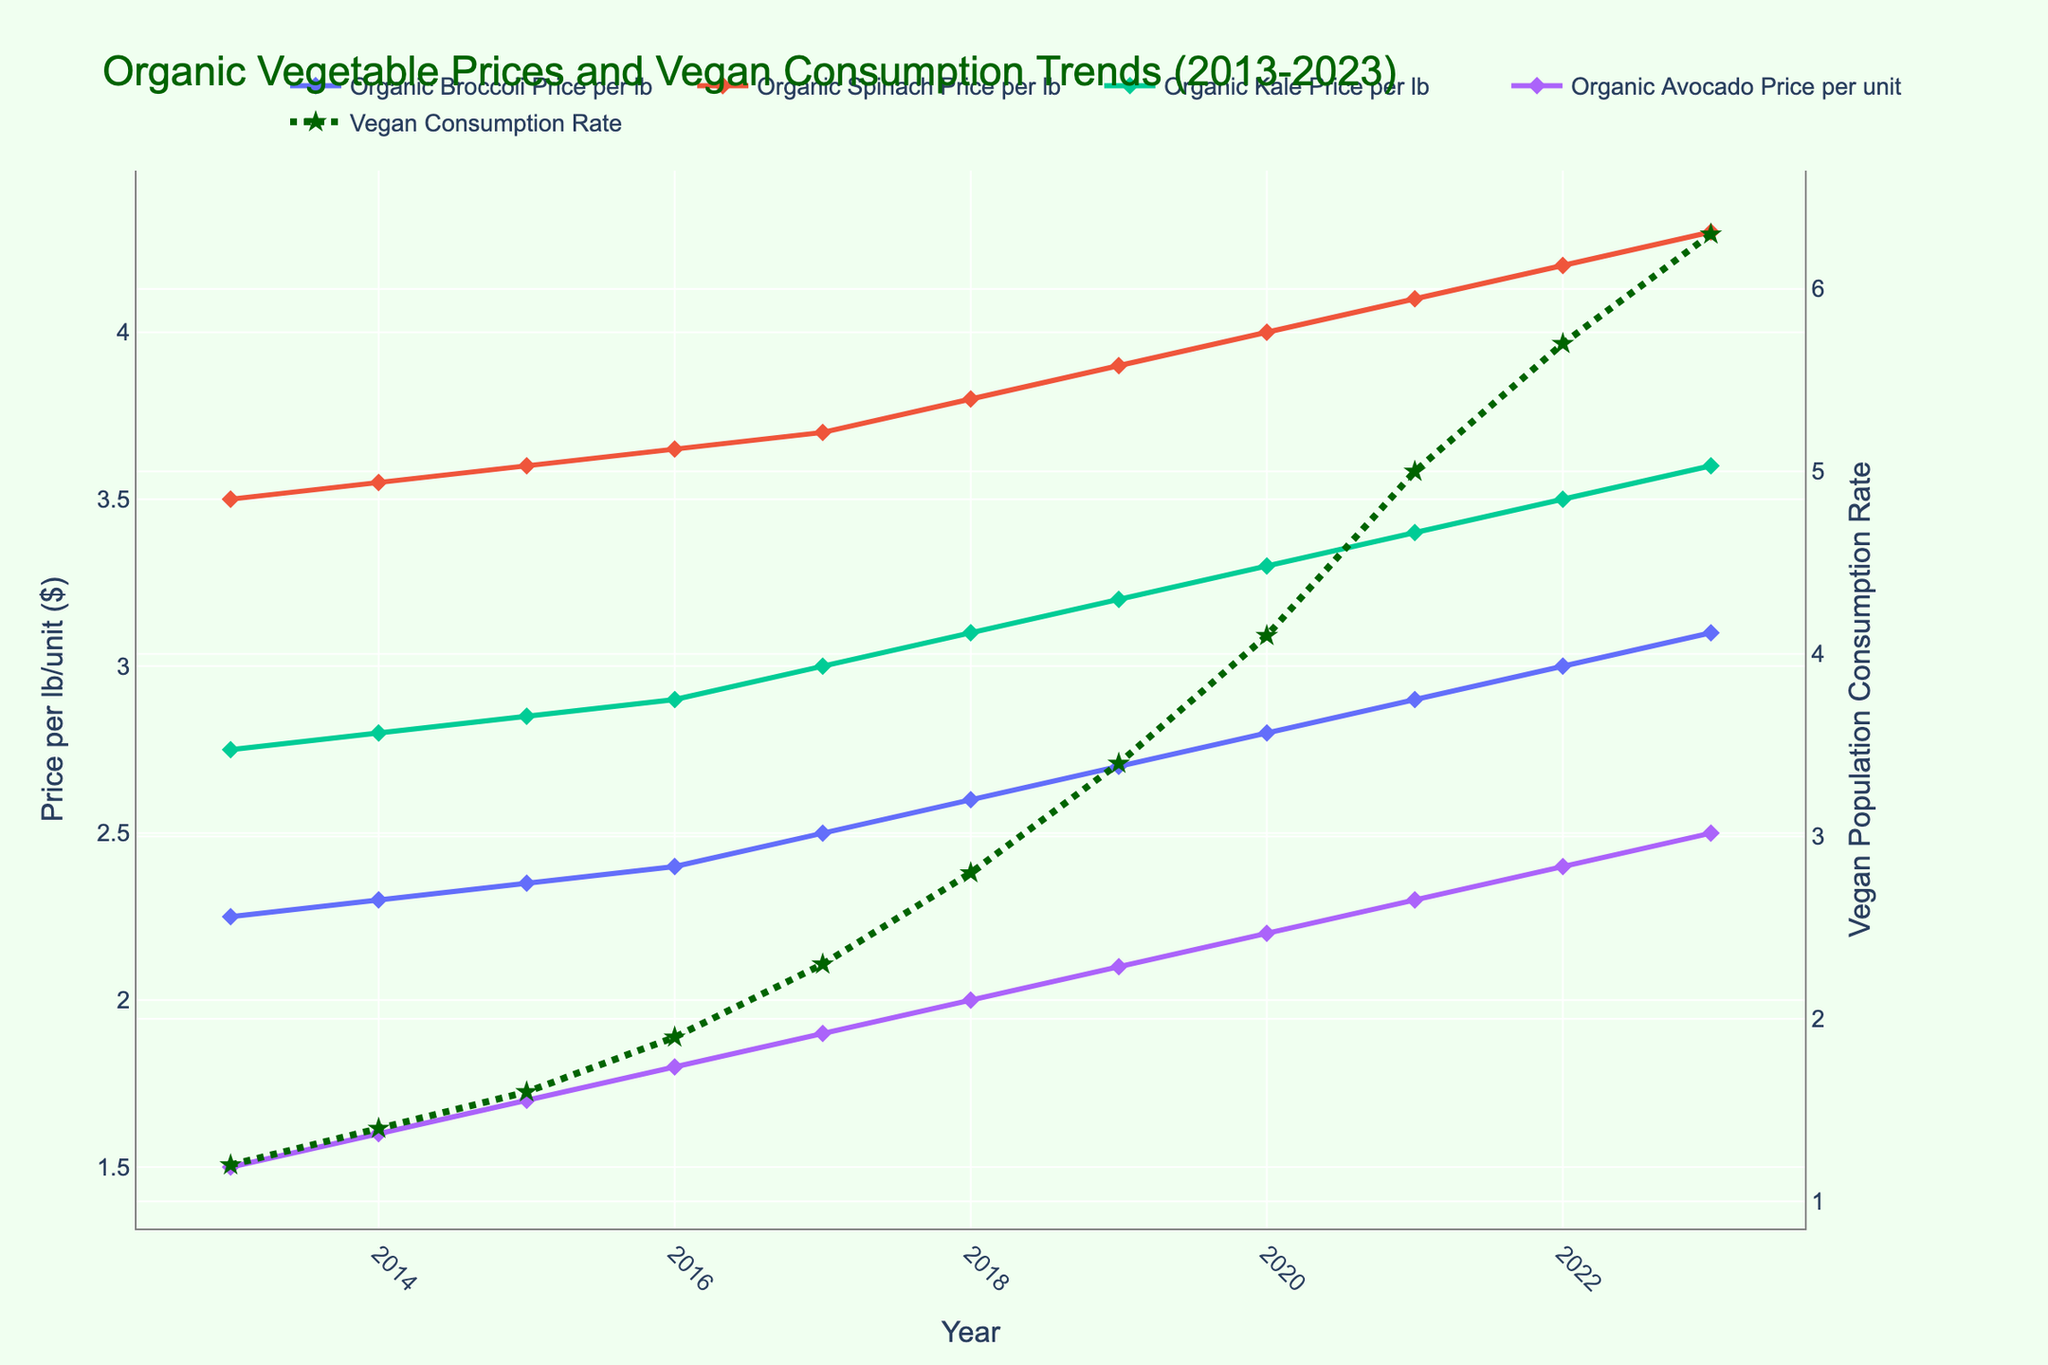What is the title of the figure? The title is located at the top of the plot and it is written in a larger and distinct font compared to the other text. The title is "Organic Vegetable Prices and Vegan Consumption Trends (2013-2023)"
Answer: Organic Vegetable Prices and Vegan Consumption Trends (2013-2023) What are the units used for the prices of the vegetables? The unit for the prices is indicated in the y-axis title on the primary y-axis (left side). It mentions "Price per lb/unit ($)", implying dollars per pound or per unit.
Answer: Dollars per lb/unit Which vegetable had the highest price per lb/unit in 2023? By looking at the end of the data lines for each vegetable in 2023, the line representing "Organic Spinach Price per lb" reaches the highest value compared to other lines.
Answer: Organic Spinach By how much did the vegan population consumption rate increase from 2014 to 2023? First, locate the data points for the consumption rate in 2014 and 2023. In 2014, it is 1.4, and in 2023, it is 6.3. Subtract the 2014 value from the 2023 value: 6.3 - 1.4 = 4.9
Answer: 4.9 Which organic vegetable price showed the least variation over the decade? By observing the smoothness and range of the lines over the years, "Organic Broccoli Price per lb" seems to have the smallest variation as its line remains relatively less steep compared to others.
Answer: Organic Broccoli In which year did the vegan population consumption rate surpass 2.0? Locate the consumption rate line and check the year when it exceeds 2.0. This happens around 2017.
Answer: 2017 How much did the price of organic avocado increase from 2017 to 2023? Locate the data points for organic avocado prices in 2017 and 2023. In 2017, it is 1.90, and in 2023, it is 2.50. Calculate the difference: 2.50 - 1.90 = 0.60.
Answer: 0.60 Did the price of any vegetable decrease at any point during the decade? Examine the trend lines for all vegetables from left to right. None of the lines show a downward trend, indicating that no vegetable price decreased.
Answer: No What was the general trend of the vegan population consumption rate from 2013 to 2023? Observe the line for "Vegan Population Consumption Rate". It shows a consistent upward trend, indicating an increase over time.
Answer: Increasing Which vegetable experienced the highest price increase percentage from 2013 to 2023? To find the highest price increase percentage, calculate the percentage increase for each vegetable. For example, for Organic Spinach: (4.30 - 3.50) / 3.50 * 100% ≈ 22.86%. Do similar calculations for each vegetable. Organic Avocado has the highest increase: (2.50 - 1.50) / 1.50 * 100% ≈ 66.67%.
Answer: Organic Avocado 